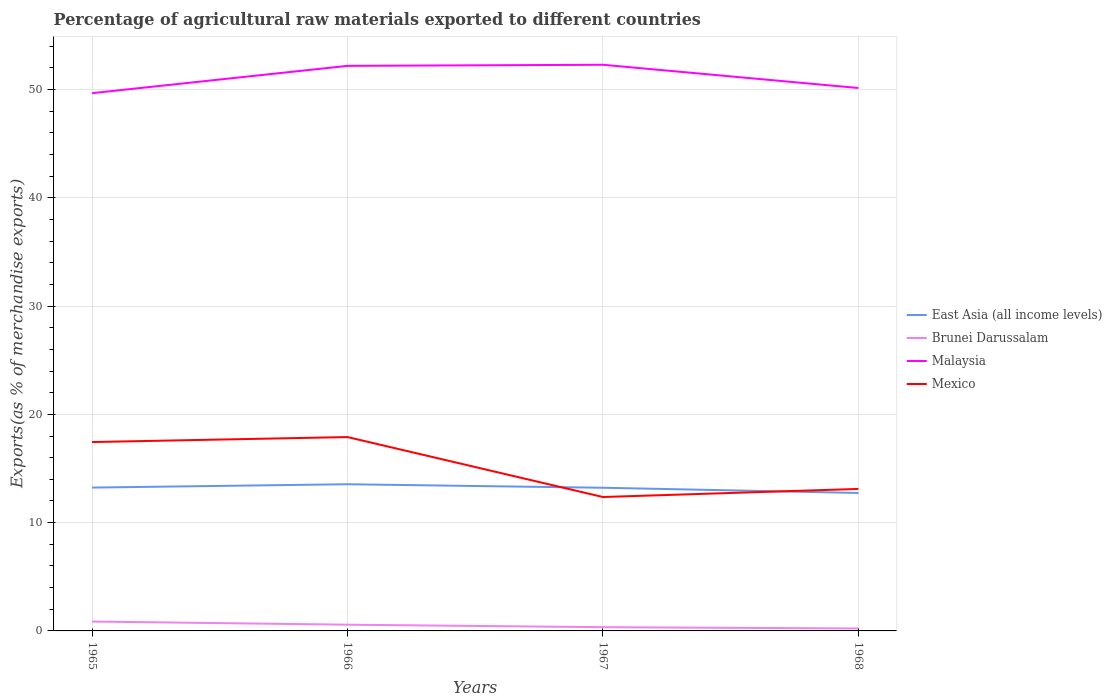Does the line corresponding to East Asia (all income levels) intersect with the line corresponding to Mexico?
Make the answer very short. Yes. Is the number of lines equal to the number of legend labels?
Ensure brevity in your answer.  Yes. Across all years, what is the maximum percentage of exports to different countries in Brunei Darussalam?
Ensure brevity in your answer.  0.23. In which year was the percentage of exports to different countries in East Asia (all income levels) maximum?
Provide a short and direct response. 1968. What is the total percentage of exports to different countries in Brunei Darussalam in the graph?
Your answer should be compact. 0.35. What is the difference between the highest and the second highest percentage of exports to different countries in Mexico?
Keep it short and to the point. 5.54. Is the percentage of exports to different countries in East Asia (all income levels) strictly greater than the percentage of exports to different countries in Brunei Darussalam over the years?
Offer a very short reply. No. How many years are there in the graph?
Keep it short and to the point. 4. How many legend labels are there?
Offer a terse response. 4. What is the title of the graph?
Your answer should be very brief. Percentage of agricultural raw materials exported to different countries. What is the label or title of the Y-axis?
Offer a terse response. Exports(as % of merchandise exports). What is the Exports(as % of merchandise exports) of East Asia (all income levels) in 1965?
Your response must be concise. 13.24. What is the Exports(as % of merchandise exports) in Brunei Darussalam in 1965?
Your answer should be compact. 0.87. What is the Exports(as % of merchandise exports) of Malaysia in 1965?
Offer a very short reply. 49.67. What is the Exports(as % of merchandise exports) in Mexico in 1965?
Provide a short and direct response. 17.44. What is the Exports(as % of merchandise exports) in East Asia (all income levels) in 1966?
Offer a very short reply. 13.55. What is the Exports(as % of merchandise exports) of Brunei Darussalam in 1966?
Give a very brief answer. 0.58. What is the Exports(as % of merchandise exports) in Malaysia in 1966?
Your answer should be compact. 52.19. What is the Exports(as % of merchandise exports) in Mexico in 1966?
Give a very brief answer. 17.91. What is the Exports(as % of merchandise exports) in East Asia (all income levels) in 1967?
Keep it short and to the point. 13.22. What is the Exports(as % of merchandise exports) in Brunei Darussalam in 1967?
Make the answer very short. 0.34. What is the Exports(as % of merchandise exports) of Malaysia in 1967?
Your answer should be very brief. 52.29. What is the Exports(as % of merchandise exports) in Mexico in 1967?
Offer a very short reply. 12.37. What is the Exports(as % of merchandise exports) of East Asia (all income levels) in 1968?
Your answer should be compact. 12.74. What is the Exports(as % of merchandise exports) in Brunei Darussalam in 1968?
Provide a succinct answer. 0.23. What is the Exports(as % of merchandise exports) of Malaysia in 1968?
Your response must be concise. 50.14. What is the Exports(as % of merchandise exports) in Mexico in 1968?
Provide a succinct answer. 13.12. Across all years, what is the maximum Exports(as % of merchandise exports) in East Asia (all income levels)?
Ensure brevity in your answer.  13.55. Across all years, what is the maximum Exports(as % of merchandise exports) in Brunei Darussalam?
Offer a very short reply. 0.87. Across all years, what is the maximum Exports(as % of merchandise exports) of Malaysia?
Provide a succinct answer. 52.29. Across all years, what is the maximum Exports(as % of merchandise exports) of Mexico?
Your answer should be compact. 17.91. Across all years, what is the minimum Exports(as % of merchandise exports) of East Asia (all income levels)?
Keep it short and to the point. 12.74. Across all years, what is the minimum Exports(as % of merchandise exports) in Brunei Darussalam?
Provide a succinct answer. 0.23. Across all years, what is the minimum Exports(as % of merchandise exports) in Malaysia?
Your answer should be very brief. 49.67. Across all years, what is the minimum Exports(as % of merchandise exports) of Mexico?
Make the answer very short. 12.37. What is the total Exports(as % of merchandise exports) in East Asia (all income levels) in the graph?
Provide a succinct answer. 52.75. What is the total Exports(as % of merchandise exports) of Brunei Darussalam in the graph?
Make the answer very short. 2.01. What is the total Exports(as % of merchandise exports) in Malaysia in the graph?
Your answer should be very brief. 204.29. What is the total Exports(as % of merchandise exports) in Mexico in the graph?
Your answer should be compact. 60.83. What is the difference between the Exports(as % of merchandise exports) in East Asia (all income levels) in 1965 and that in 1966?
Your response must be concise. -0.31. What is the difference between the Exports(as % of merchandise exports) in Brunei Darussalam in 1965 and that in 1966?
Ensure brevity in your answer.  0.29. What is the difference between the Exports(as % of merchandise exports) in Malaysia in 1965 and that in 1966?
Offer a terse response. -2.52. What is the difference between the Exports(as % of merchandise exports) in Mexico in 1965 and that in 1966?
Ensure brevity in your answer.  -0.46. What is the difference between the Exports(as % of merchandise exports) of East Asia (all income levels) in 1965 and that in 1967?
Ensure brevity in your answer.  0.02. What is the difference between the Exports(as % of merchandise exports) of Brunei Darussalam in 1965 and that in 1967?
Ensure brevity in your answer.  0.52. What is the difference between the Exports(as % of merchandise exports) of Malaysia in 1965 and that in 1967?
Provide a succinct answer. -2.62. What is the difference between the Exports(as % of merchandise exports) in Mexico in 1965 and that in 1967?
Ensure brevity in your answer.  5.08. What is the difference between the Exports(as % of merchandise exports) in East Asia (all income levels) in 1965 and that in 1968?
Make the answer very short. 0.5. What is the difference between the Exports(as % of merchandise exports) of Brunei Darussalam in 1965 and that in 1968?
Your response must be concise. 0.64. What is the difference between the Exports(as % of merchandise exports) in Malaysia in 1965 and that in 1968?
Provide a short and direct response. -0.48. What is the difference between the Exports(as % of merchandise exports) of Mexico in 1965 and that in 1968?
Provide a short and direct response. 4.33. What is the difference between the Exports(as % of merchandise exports) in East Asia (all income levels) in 1966 and that in 1967?
Your response must be concise. 0.32. What is the difference between the Exports(as % of merchandise exports) in Brunei Darussalam in 1966 and that in 1967?
Make the answer very short. 0.23. What is the difference between the Exports(as % of merchandise exports) in Malaysia in 1966 and that in 1967?
Your response must be concise. -0.1. What is the difference between the Exports(as % of merchandise exports) in Mexico in 1966 and that in 1967?
Your answer should be very brief. 5.54. What is the difference between the Exports(as % of merchandise exports) in East Asia (all income levels) in 1966 and that in 1968?
Your answer should be compact. 0.81. What is the difference between the Exports(as % of merchandise exports) in Brunei Darussalam in 1966 and that in 1968?
Keep it short and to the point. 0.35. What is the difference between the Exports(as % of merchandise exports) in Malaysia in 1966 and that in 1968?
Make the answer very short. 2.05. What is the difference between the Exports(as % of merchandise exports) in Mexico in 1966 and that in 1968?
Your response must be concise. 4.79. What is the difference between the Exports(as % of merchandise exports) of East Asia (all income levels) in 1967 and that in 1968?
Offer a very short reply. 0.48. What is the difference between the Exports(as % of merchandise exports) in Brunei Darussalam in 1967 and that in 1968?
Ensure brevity in your answer.  0.12. What is the difference between the Exports(as % of merchandise exports) in Malaysia in 1967 and that in 1968?
Make the answer very short. 2.15. What is the difference between the Exports(as % of merchandise exports) in Mexico in 1967 and that in 1968?
Your answer should be very brief. -0.75. What is the difference between the Exports(as % of merchandise exports) in East Asia (all income levels) in 1965 and the Exports(as % of merchandise exports) in Brunei Darussalam in 1966?
Your response must be concise. 12.66. What is the difference between the Exports(as % of merchandise exports) in East Asia (all income levels) in 1965 and the Exports(as % of merchandise exports) in Malaysia in 1966?
Provide a short and direct response. -38.95. What is the difference between the Exports(as % of merchandise exports) of East Asia (all income levels) in 1965 and the Exports(as % of merchandise exports) of Mexico in 1966?
Offer a terse response. -4.67. What is the difference between the Exports(as % of merchandise exports) in Brunei Darussalam in 1965 and the Exports(as % of merchandise exports) in Malaysia in 1966?
Keep it short and to the point. -51.32. What is the difference between the Exports(as % of merchandise exports) in Brunei Darussalam in 1965 and the Exports(as % of merchandise exports) in Mexico in 1966?
Provide a succinct answer. -17.04. What is the difference between the Exports(as % of merchandise exports) of Malaysia in 1965 and the Exports(as % of merchandise exports) of Mexico in 1966?
Keep it short and to the point. 31.76. What is the difference between the Exports(as % of merchandise exports) in East Asia (all income levels) in 1965 and the Exports(as % of merchandise exports) in Brunei Darussalam in 1967?
Make the answer very short. 12.89. What is the difference between the Exports(as % of merchandise exports) in East Asia (all income levels) in 1965 and the Exports(as % of merchandise exports) in Malaysia in 1967?
Keep it short and to the point. -39.05. What is the difference between the Exports(as % of merchandise exports) in East Asia (all income levels) in 1965 and the Exports(as % of merchandise exports) in Mexico in 1967?
Give a very brief answer. 0.87. What is the difference between the Exports(as % of merchandise exports) of Brunei Darussalam in 1965 and the Exports(as % of merchandise exports) of Malaysia in 1967?
Give a very brief answer. -51.42. What is the difference between the Exports(as % of merchandise exports) of Brunei Darussalam in 1965 and the Exports(as % of merchandise exports) of Mexico in 1967?
Ensure brevity in your answer.  -11.5. What is the difference between the Exports(as % of merchandise exports) in Malaysia in 1965 and the Exports(as % of merchandise exports) in Mexico in 1967?
Give a very brief answer. 37.3. What is the difference between the Exports(as % of merchandise exports) in East Asia (all income levels) in 1965 and the Exports(as % of merchandise exports) in Brunei Darussalam in 1968?
Offer a very short reply. 13.01. What is the difference between the Exports(as % of merchandise exports) in East Asia (all income levels) in 1965 and the Exports(as % of merchandise exports) in Malaysia in 1968?
Give a very brief answer. -36.9. What is the difference between the Exports(as % of merchandise exports) of East Asia (all income levels) in 1965 and the Exports(as % of merchandise exports) of Mexico in 1968?
Offer a very short reply. 0.12. What is the difference between the Exports(as % of merchandise exports) of Brunei Darussalam in 1965 and the Exports(as % of merchandise exports) of Malaysia in 1968?
Your answer should be compact. -49.27. What is the difference between the Exports(as % of merchandise exports) of Brunei Darussalam in 1965 and the Exports(as % of merchandise exports) of Mexico in 1968?
Make the answer very short. -12.25. What is the difference between the Exports(as % of merchandise exports) in Malaysia in 1965 and the Exports(as % of merchandise exports) in Mexico in 1968?
Give a very brief answer. 36.55. What is the difference between the Exports(as % of merchandise exports) of East Asia (all income levels) in 1966 and the Exports(as % of merchandise exports) of Brunei Darussalam in 1967?
Your answer should be very brief. 13.2. What is the difference between the Exports(as % of merchandise exports) in East Asia (all income levels) in 1966 and the Exports(as % of merchandise exports) in Malaysia in 1967?
Your answer should be very brief. -38.74. What is the difference between the Exports(as % of merchandise exports) of East Asia (all income levels) in 1966 and the Exports(as % of merchandise exports) of Mexico in 1967?
Offer a terse response. 1.18. What is the difference between the Exports(as % of merchandise exports) of Brunei Darussalam in 1966 and the Exports(as % of merchandise exports) of Malaysia in 1967?
Your answer should be compact. -51.71. What is the difference between the Exports(as % of merchandise exports) in Brunei Darussalam in 1966 and the Exports(as % of merchandise exports) in Mexico in 1967?
Ensure brevity in your answer.  -11.79. What is the difference between the Exports(as % of merchandise exports) of Malaysia in 1966 and the Exports(as % of merchandise exports) of Mexico in 1967?
Provide a succinct answer. 39.82. What is the difference between the Exports(as % of merchandise exports) in East Asia (all income levels) in 1966 and the Exports(as % of merchandise exports) in Brunei Darussalam in 1968?
Give a very brief answer. 13.32. What is the difference between the Exports(as % of merchandise exports) of East Asia (all income levels) in 1966 and the Exports(as % of merchandise exports) of Malaysia in 1968?
Your answer should be compact. -36.59. What is the difference between the Exports(as % of merchandise exports) in East Asia (all income levels) in 1966 and the Exports(as % of merchandise exports) in Mexico in 1968?
Make the answer very short. 0.43. What is the difference between the Exports(as % of merchandise exports) of Brunei Darussalam in 1966 and the Exports(as % of merchandise exports) of Malaysia in 1968?
Offer a very short reply. -49.57. What is the difference between the Exports(as % of merchandise exports) in Brunei Darussalam in 1966 and the Exports(as % of merchandise exports) in Mexico in 1968?
Ensure brevity in your answer.  -12.54. What is the difference between the Exports(as % of merchandise exports) of Malaysia in 1966 and the Exports(as % of merchandise exports) of Mexico in 1968?
Offer a terse response. 39.07. What is the difference between the Exports(as % of merchandise exports) in East Asia (all income levels) in 1967 and the Exports(as % of merchandise exports) in Brunei Darussalam in 1968?
Offer a very short reply. 13. What is the difference between the Exports(as % of merchandise exports) of East Asia (all income levels) in 1967 and the Exports(as % of merchandise exports) of Malaysia in 1968?
Give a very brief answer. -36.92. What is the difference between the Exports(as % of merchandise exports) of East Asia (all income levels) in 1967 and the Exports(as % of merchandise exports) of Mexico in 1968?
Give a very brief answer. 0.11. What is the difference between the Exports(as % of merchandise exports) in Brunei Darussalam in 1967 and the Exports(as % of merchandise exports) in Malaysia in 1968?
Provide a succinct answer. -49.8. What is the difference between the Exports(as % of merchandise exports) of Brunei Darussalam in 1967 and the Exports(as % of merchandise exports) of Mexico in 1968?
Ensure brevity in your answer.  -12.77. What is the difference between the Exports(as % of merchandise exports) of Malaysia in 1967 and the Exports(as % of merchandise exports) of Mexico in 1968?
Offer a terse response. 39.17. What is the average Exports(as % of merchandise exports) in East Asia (all income levels) per year?
Your answer should be compact. 13.19. What is the average Exports(as % of merchandise exports) in Brunei Darussalam per year?
Provide a succinct answer. 0.5. What is the average Exports(as % of merchandise exports) in Malaysia per year?
Your answer should be very brief. 51.07. What is the average Exports(as % of merchandise exports) in Mexico per year?
Ensure brevity in your answer.  15.21. In the year 1965, what is the difference between the Exports(as % of merchandise exports) in East Asia (all income levels) and Exports(as % of merchandise exports) in Brunei Darussalam?
Your answer should be compact. 12.37. In the year 1965, what is the difference between the Exports(as % of merchandise exports) in East Asia (all income levels) and Exports(as % of merchandise exports) in Malaysia?
Ensure brevity in your answer.  -36.43. In the year 1965, what is the difference between the Exports(as % of merchandise exports) of East Asia (all income levels) and Exports(as % of merchandise exports) of Mexico?
Your response must be concise. -4.21. In the year 1965, what is the difference between the Exports(as % of merchandise exports) of Brunei Darussalam and Exports(as % of merchandise exports) of Malaysia?
Your answer should be compact. -48.8. In the year 1965, what is the difference between the Exports(as % of merchandise exports) of Brunei Darussalam and Exports(as % of merchandise exports) of Mexico?
Ensure brevity in your answer.  -16.58. In the year 1965, what is the difference between the Exports(as % of merchandise exports) in Malaysia and Exports(as % of merchandise exports) in Mexico?
Your answer should be compact. 32.22. In the year 1966, what is the difference between the Exports(as % of merchandise exports) in East Asia (all income levels) and Exports(as % of merchandise exports) in Brunei Darussalam?
Your answer should be compact. 12.97. In the year 1966, what is the difference between the Exports(as % of merchandise exports) in East Asia (all income levels) and Exports(as % of merchandise exports) in Malaysia?
Make the answer very short. -38.64. In the year 1966, what is the difference between the Exports(as % of merchandise exports) in East Asia (all income levels) and Exports(as % of merchandise exports) in Mexico?
Offer a terse response. -4.36. In the year 1966, what is the difference between the Exports(as % of merchandise exports) in Brunei Darussalam and Exports(as % of merchandise exports) in Malaysia?
Give a very brief answer. -51.61. In the year 1966, what is the difference between the Exports(as % of merchandise exports) of Brunei Darussalam and Exports(as % of merchandise exports) of Mexico?
Give a very brief answer. -17.33. In the year 1966, what is the difference between the Exports(as % of merchandise exports) of Malaysia and Exports(as % of merchandise exports) of Mexico?
Your response must be concise. 34.28. In the year 1967, what is the difference between the Exports(as % of merchandise exports) in East Asia (all income levels) and Exports(as % of merchandise exports) in Brunei Darussalam?
Your answer should be very brief. 12.88. In the year 1967, what is the difference between the Exports(as % of merchandise exports) in East Asia (all income levels) and Exports(as % of merchandise exports) in Malaysia?
Give a very brief answer. -39.07. In the year 1967, what is the difference between the Exports(as % of merchandise exports) in East Asia (all income levels) and Exports(as % of merchandise exports) in Mexico?
Keep it short and to the point. 0.86. In the year 1967, what is the difference between the Exports(as % of merchandise exports) in Brunei Darussalam and Exports(as % of merchandise exports) in Malaysia?
Your answer should be compact. -51.95. In the year 1967, what is the difference between the Exports(as % of merchandise exports) of Brunei Darussalam and Exports(as % of merchandise exports) of Mexico?
Ensure brevity in your answer.  -12.02. In the year 1967, what is the difference between the Exports(as % of merchandise exports) of Malaysia and Exports(as % of merchandise exports) of Mexico?
Make the answer very short. 39.92. In the year 1968, what is the difference between the Exports(as % of merchandise exports) in East Asia (all income levels) and Exports(as % of merchandise exports) in Brunei Darussalam?
Your answer should be very brief. 12.52. In the year 1968, what is the difference between the Exports(as % of merchandise exports) of East Asia (all income levels) and Exports(as % of merchandise exports) of Malaysia?
Your answer should be very brief. -37.4. In the year 1968, what is the difference between the Exports(as % of merchandise exports) of East Asia (all income levels) and Exports(as % of merchandise exports) of Mexico?
Give a very brief answer. -0.37. In the year 1968, what is the difference between the Exports(as % of merchandise exports) of Brunei Darussalam and Exports(as % of merchandise exports) of Malaysia?
Offer a terse response. -49.92. In the year 1968, what is the difference between the Exports(as % of merchandise exports) in Brunei Darussalam and Exports(as % of merchandise exports) in Mexico?
Make the answer very short. -12.89. In the year 1968, what is the difference between the Exports(as % of merchandise exports) of Malaysia and Exports(as % of merchandise exports) of Mexico?
Offer a terse response. 37.03. What is the ratio of the Exports(as % of merchandise exports) in East Asia (all income levels) in 1965 to that in 1966?
Keep it short and to the point. 0.98. What is the ratio of the Exports(as % of merchandise exports) in Brunei Darussalam in 1965 to that in 1966?
Your response must be concise. 1.51. What is the ratio of the Exports(as % of merchandise exports) of Malaysia in 1965 to that in 1966?
Provide a succinct answer. 0.95. What is the ratio of the Exports(as % of merchandise exports) of Mexico in 1965 to that in 1966?
Provide a short and direct response. 0.97. What is the ratio of the Exports(as % of merchandise exports) of Brunei Darussalam in 1965 to that in 1967?
Give a very brief answer. 2.52. What is the ratio of the Exports(as % of merchandise exports) in Malaysia in 1965 to that in 1967?
Keep it short and to the point. 0.95. What is the ratio of the Exports(as % of merchandise exports) of Mexico in 1965 to that in 1967?
Provide a short and direct response. 1.41. What is the ratio of the Exports(as % of merchandise exports) in East Asia (all income levels) in 1965 to that in 1968?
Your answer should be compact. 1.04. What is the ratio of the Exports(as % of merchandise exports) of Brunei Darussalam in 1965 to that in 1968?
Provide a short and direct response. 3.84. What is the ratio of the Exports(as % of merchandise exports) in Malaysia in 1965 to that in 1968?
Ensure brevity in your answer.  0.99. What is the ratio of the Exports(as % of merchandise exports) in Mexico in 1965 to that in 1968?
Offer a terse response. 1.33. What is the ratio of the Exports(as % of merchandise exports) in East Asia (all income levels) in 1966 to that in 1967?
Offer a terse response. 1.02. What is the ratio of the Exports(as % of merchandise exports) in Brunei Darussalam in 1966 to that in 1967?
Provide a short and direct response. 1.67. What is the ratio of the Exports(as % of merchandise exports) of Malaysia in 1966 to that in 1967?
Provide a short and direct response. 1. What is the ratio of the Exports(as % of merchandise exports) in Mexico in 1966 to that in 1967?
Keep it short and to the point. 1.45. What is the ratio of the Exports(as % of merchandise exports) in East Asia (all income levels) in 1966 to that in 1968?
Offer a very short reply. 1.06. What is the ratio of the Exports(as % of merchandise exports) in Brunei Darussalam in 1966 to that in 1968?
Your response must be concise. 2.55. What is the ratio of the Exports(as % of merchandise exports) of Malaysia in 1966 to that in 1968?
Keep it short and to the point. 1.04. What is the ratio of the Exports(as % of merchandise exports) of Mexico in 1966 to that in 1968?
Your response must be concise. 1.37. What is the ratio of the Exports(as % of merchandise exports) in East Asia (all income levels) in 1967 to that in 1968?
Your response must be concise. 1.04. What is the ratio of the Exports(as % of merchandise exports) of Brunei Darussalam in 1967 to that in 1968?
Make the answer very short. 1.53. What is the ratio of the Exports(as % of merchandise exports) of Malaysia in 1967 to that in 1968?
Provide a short and direct response. 1.04. What is the ratio of the Exports(as % of merchandise exports) in Mexico in 1967 to that in 1968?
Your answer should be compact. 0.94. What is the difference between the highest and the second highest Exports(as % of merchandise exports) in East Asia (all income levels)?
Your answer should be very brief. 0.31. What is the difference between the highest and the second highest Exports(as % of merchandise exports) of Brunei Darussalam?
Offer a very short reply. 0.29. What is the difference between the highest and the second highest Exports(as % of merchandise exports) in Malaysia?
Your answer should be very brief. 0.1. What is the difference between the highest and the second highest Exports(as % of merchandise exports) of Mexico?
Your response must be concise. 0.46. What is the difference between the highest and the lowest Exports(as % of merchandise exports) in East Asia (all income levels)?
Make the answer very short. 0.81. What is the difference between the highest and the lowest Exports(as % of merchandise exports) of Brunei Darussalam?
Make the answer very short. 0.64. What is the difference between the highest and the lowest Exports(as % of merchandise exports) in Malaysia?
Provide a short and direct response. 2.62. What is the difference between the highest and the lowest Exports(as % of merchandise exports) in Mexico?
Your answer should be compact. 5.54. 